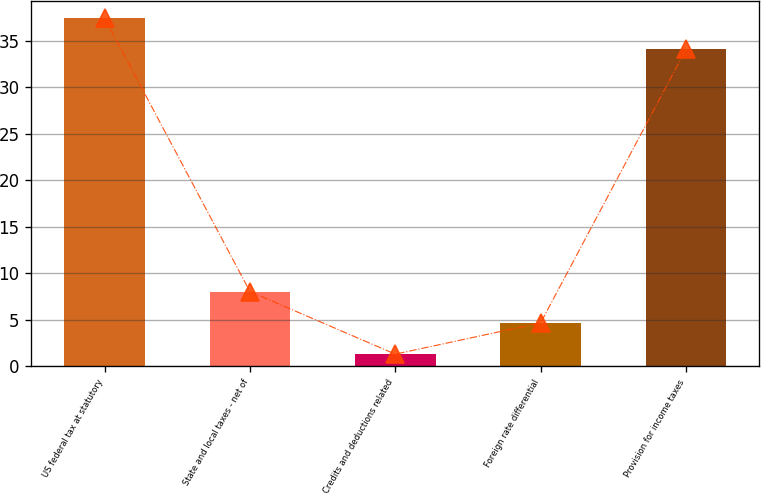Convert chart to OTSL. <chart><loc_0><loc_0><loc_500><loc_500><bar_chart><fcel>US federal tax at statutory<fcel>State and local taxes - net of<fcel>Credits and deductions related<fcel>Foreign rate differential<fcel>Provision for income taxes<nl><fcel>37.47<fcel>8.04<fcel>1.3<fcel>4.67<fcel>34.1<nl></chart> 